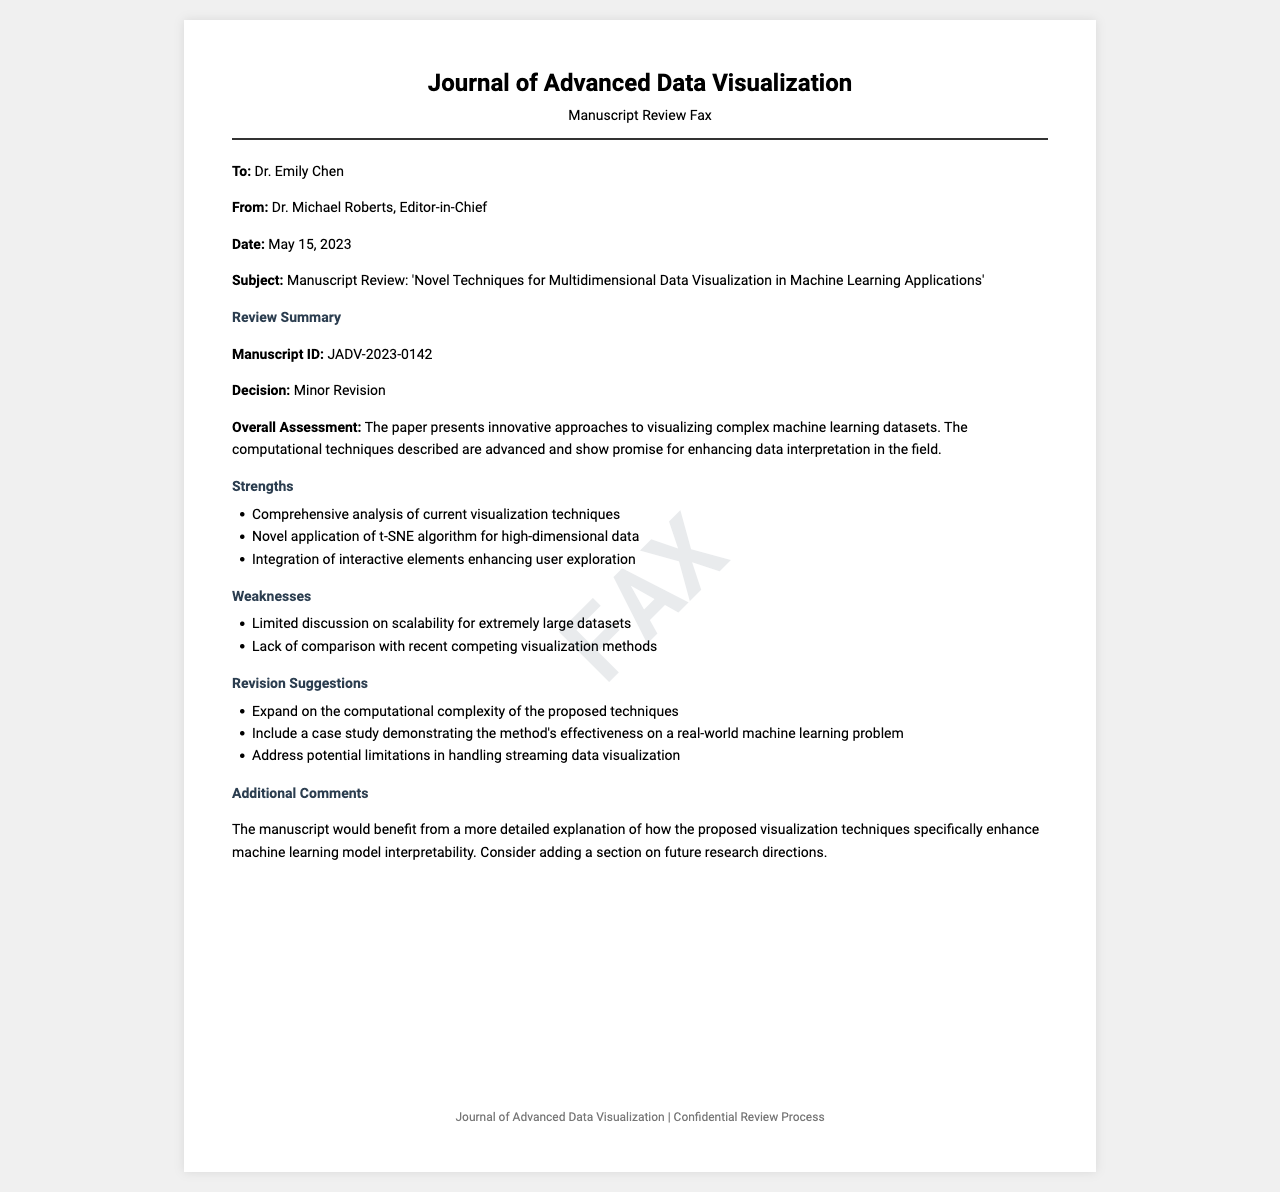What is the manuscript ID? The manuscript ID is a unique identifier for the paper being reviewed. It is specifically mentioned in the review summary section of the document.
Answer: JADV-2023-0142 Who is the editor-in-chief? The editor-in-chief's name is the individual responsible for the manuscript review process, stated at the beginning of the document.
Answer: Dr. Michael Roberts What is the decision on the manuscript? The decision indicates the outcome of the review process as stated in the review summary section.
Answer: Minor Revision What is one strength of the manuscript? The strengths highlight the positive aspects of the research and are listed in the strengths section.
Answer: Comprehensive analysis of current visualization techniques What is one weakness noted in the review? Weaknesses refer to the limitations or areas needing improvement and are specified in their respective section of the document.
Answer: Limited discussion on scalability for extremely large datasets What is one revision suggestion provided? Revision suggestions are recommendations for improvements mentioned to address the manuscript's weaknesses.
Answer: Expand on the computational complexity of the proposed techniques What is the date of the fax? The date indicates when this manuscript review was communicated, found in the metadata section.
Answer: May 15, 2023 What is the subject of the manuscript review? The subject is the title of the manuscript being reviewed and provides an overview of the research focus.
Answer: Novel Techniques for Multidimensional Data Visualization in Machine Learning Applications What additional comment is made regarding the manuscript? Additional comments provide further feedback which may enhance the manuscript's value, mentioned in the respective section.
Answer: The manuscript would benefit from a more detailed explanation of how the proposed visualization techniques specifically enhance machine learning model interpretability 